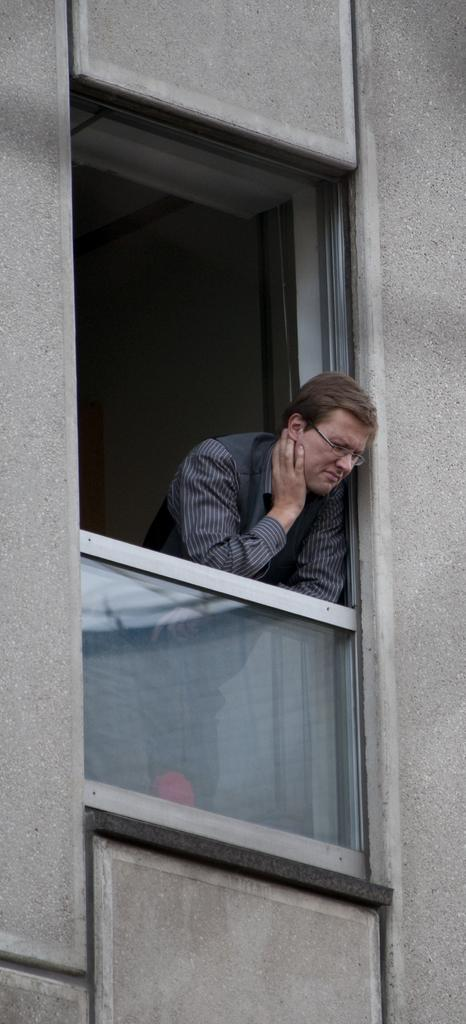What is the main subject of the image? There is a man standing in the image. What can be seen on the man's face? The man is wearing spectacles. What type of clothing is the man wearing? The man is wearing a shirt. What architectural features are present in the image? There is a window and a wall in the image. Can you see any fairies flying around the man in the image? There are no fairies present in the image. Is there a bomb visible in the image? There is no bomb present in the image. 